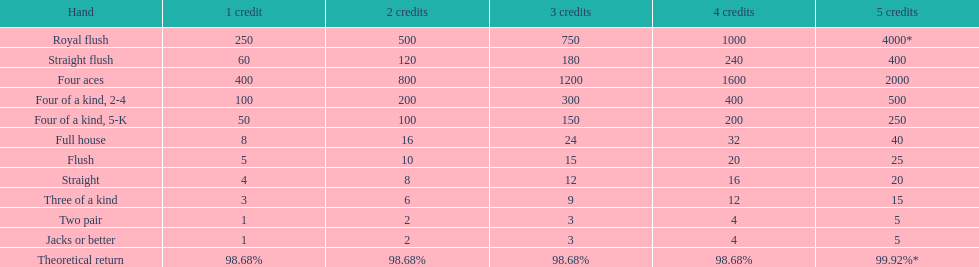Is four 5s worth more or less than four 2s? Less. 